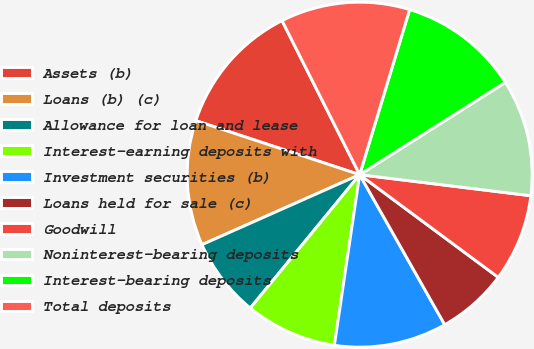Convert chart to OTSL. <chart><loc_0><loc_0><loc_500><loc_500><pie_chart><fcel>Assets (b)<fcel>Loans (b) (c)<fcel>Allowance for loan and lease<fcel>Interest-earning deposits with<fcel>Investment securities (b)<fcel>Loans held for sale (c)<fcel>Goodwill<fcel>Noninterest-bearing deposits<fcel>Interest-bearing deposits<fcel>Total deposits<nl><fcel>12.5%<fcel>11.72%<fcel>7.42%<fcel>8.59%<fcel>10.55%<fcel>6.64%<fcel>8.2%<fcel>10.94%<fcel>11.33%<fcel>12.11%<nl></chart> 